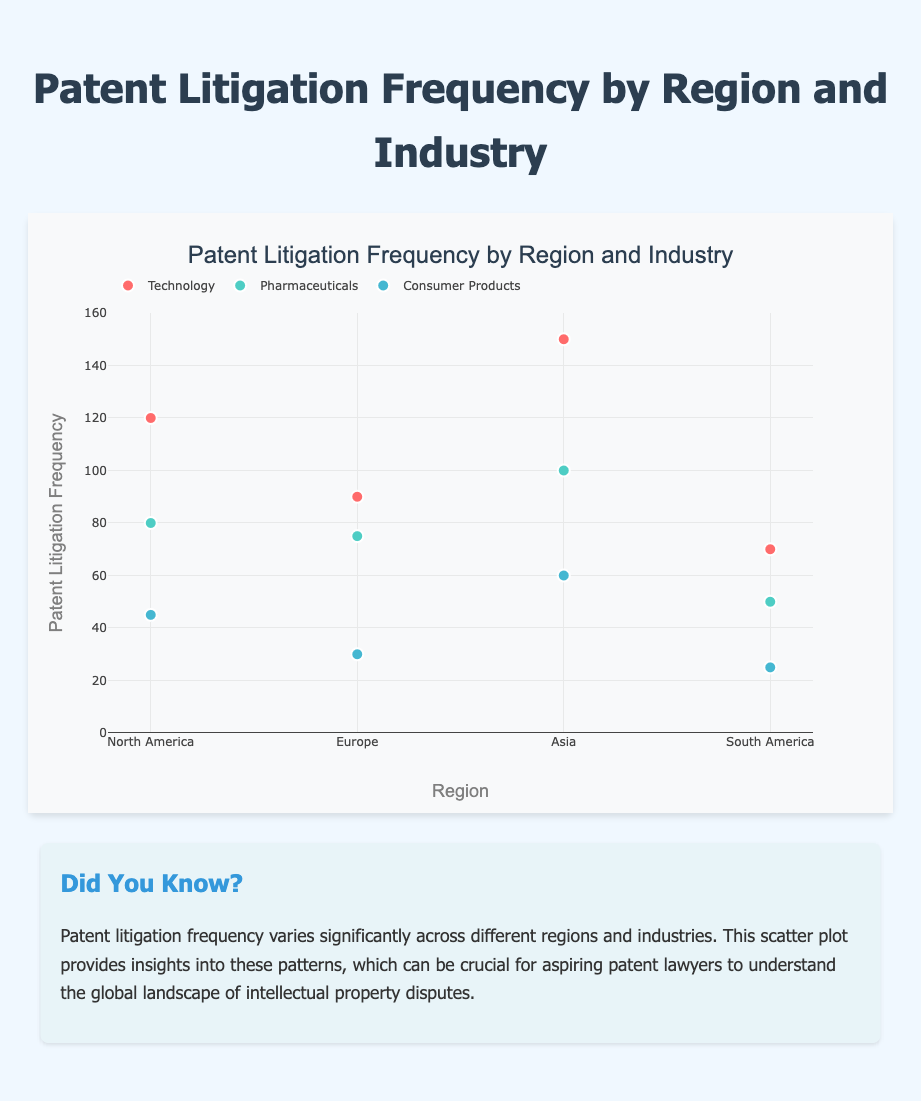What's the title of the chart? The title is shown prominently above the plot.
Answer: Patent Litigation Frequency by Region and Industry What does the x-axis represent? The x-axis is labeled 'Region', indicating different geographic areas.
Answer: Region Which region has the highest patent litigation frequency for the Technology industry? By looking at the scatter points for the Technology industry, the highest frequency point is in Asia.
Answer: Asia How many regions are represented in the chart? The x-axis labels represent the number of regions.
Answer: 4 What is the range of the y-axis? The y-axis starts at 0 and goes up to 160, as shown in the axis ticks.
Answer: 0-160 What is the total patent litigation frequency for the North America region? Sum the frequencies for Technology (120), Pharmaceuticals (80), and Consumer Products (45).
Answer: 245 Which industry has the lowest average patent litigation frequency? Calculate the average for each industry: Technology (107.5), Pharmaceuticals (76.25), Consumer Products (40). Consumer Products has the lowest.
Answer: Consumer Products What's the difference in litigation frequency between Technology and Consumer Products in Asia? Subtract the frequency of Consumer Products (60) from Technology (150).
Answer: 90 Is the Pharmaceuticals industry the same in all regions? Compare the points for Pharmaceuticals across regions (80, 75, 100, 50); they are different.
Answer: No How does the distribution of patents litigations compare across industries in South America? South America has Technology (70), Pharmaceuticals (50), and Consumer Products (25).
Answer: Highest in Technology, lowest in Consumer Products 